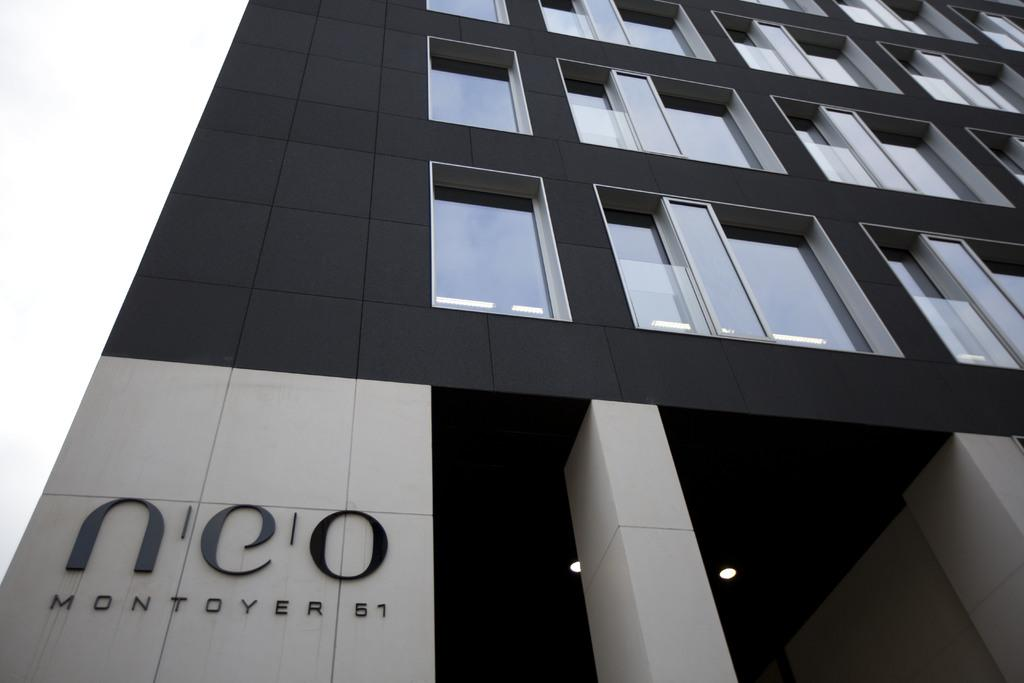What type of structure is visible in the image? There is a building in the image. How can the building be identified? The building has a name board. What type of windows are present in the building? There are glass windows in the building. Are there any architectural features visible in the building? Yes, there is a pillar in the building. What type of lighting is present in the building? There are ceiling lights in the building. What is visible in the background of the image? The sky is visible in the background of the image. What type of amusement can be seen in the cart in the image? There is no cart present in the image, and therefore no amusement can be observed. 